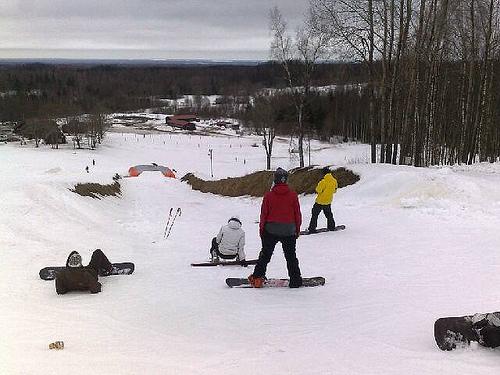How many snowboards are seen?
Write a very short answer. 5. Which direction is the snowboarder moving?
Answer briefly. Down. 3 people are not standing?
Short answer required. Yes. Where have these children likely come from?
Short answer required. Home. Is the person in the middle experienced at snowboarding?
Concise answer only. Yes. Is the snowboarder on the ground?
Concise answer only. Yes. How many people are not standing?
Concise answer only. 2. Are both persons snowboarding?
Short answer required. Yes. How many snowboards are shown here?
Write a very short answer. 5. 